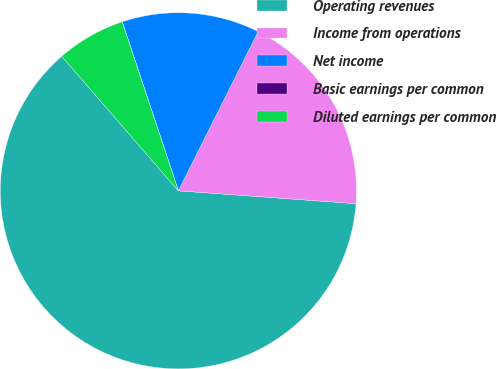Convert chart to OTSL. <chart><loc_0><loc_0><loc_500><loc_500><pie_chart><fcel>Operating revenues<fcel>Income from operations<fcel>Net income<fcel>Basic earnings per common<fcel>Diluted earnings per common<nl><fcel>62.48%<fcel>18.75%<fcel>12.5%<fcel>0.01%<fcel>6.26%<nl></chart> 